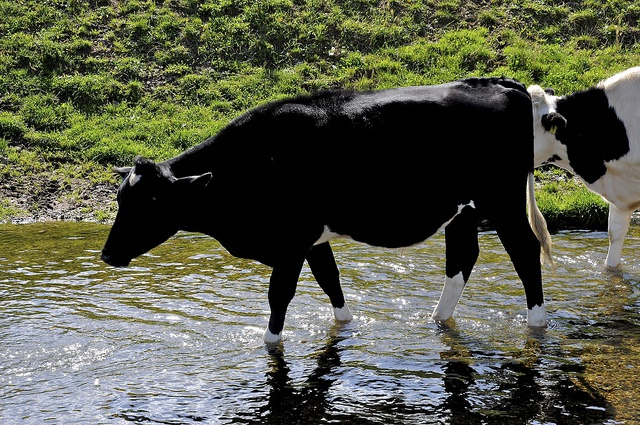Describe the objects in this image and their specific colors. I can see cow in darkgreen, black, darkgray, and gray tones and cow in darkgreen, black, and gray tones in this image. 